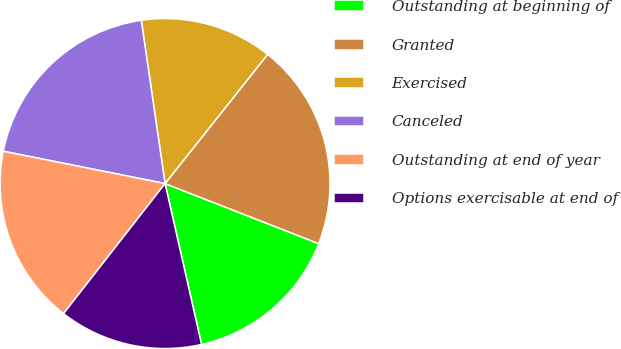Convert chart to OTSL. <chart><loc_0><loc_0><loc_500><loc_500><pie_chart><fcel>Outstanding at beginning of<fcel>Granted<fcel>Exercised<fcel>Canceled<fcel>Outstanding at end of year<fcel>Options exercisable at end of<nl><fcel>15.52%<fcel>20.25%<fcel>12.98%<fcel>19.56%<fcel>17.59%<fcel>14.1%<nl></chart> 